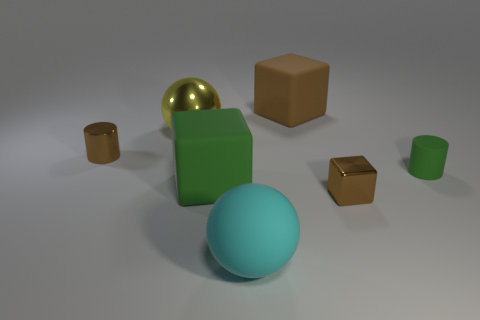What material is the brown thing that is to the left of the large cyan rubber object?
Your answer should be very brief. Metal. Is there anything else that has the same color as the large metal object?
Give a very brief answer. No. There is a yellow thing that is made of the same material as the small brown cube; what is its size?
Offer a very short reply. Large. What number of large things are brown shiny cylinders or balls?
Provide a short and direct response. 2. What is the size of the rubber cube that is in front of the small brown object to the left of the small brown thing that is in front of the small shiny cylinder?
Offer a very short reply. Large. How many other matte cylinders have the same size as the green matte cylinder?
Provide a succinct answer. 0. What number of things are tiny brown shiny objects or big objects behind the green matte cylinder?
Your answer should be compact. 4. The big brown object has what shape?
Make the answer very short. Cube. Does the tiny metallic cube have the same color as the small metallic cylinder?
Your answer should be compact. Yes. What color is the other ball that is the same size as the shiny ball?
Provide a succinct answer. Cyan. 